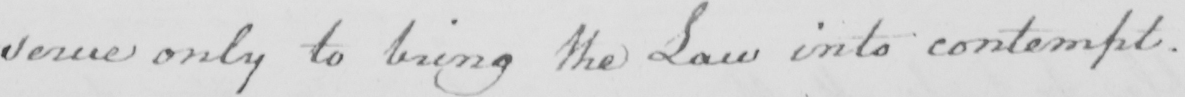Transcribe the text shown in this historical manuscript line. serve only to bring the Law into contempt . 